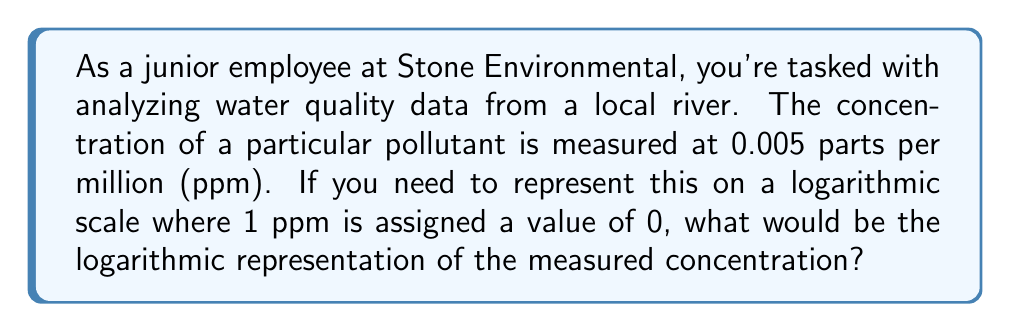Can you answer this question? To solve this problem, we'll follow these steps:

1) In a logarithmic scale, we're dealing with powers of 10. The general form of the scale is:

   $$ \text{Log value} = \log_{10}(\text{concentration}) - \log_{10}(\text{reference concentration}) $$

2) We're given that 1 ppm is assigned a value of 0 on this scale. This means 1 ppm is our reference concentration.

3) Let's plug in our values:
   - Measured concentration = 0.005 ppm
   - Reference concentration = 1 ppm

4) Now we can calculate:

   $$ \text{Log value} = \log_{10}(0.005) - \log_{10}(1) $$

5) Simplify:
   $$ \log_{10}(1) = 0 $$, so our equation becomes:
   $$ \text{Log value} = \log_{10}(0.005) - 0 = \log_{10}(0.005) $$

6) Calculate $\log_{10}(0.005)$:
   $$ \log_{10}(0.005) = \log_{10}(5 \times 10^{-3}) = \log_{10}(5) + \log_{10}(10^{-3}) = 0.6990 - 3 = -2.3010 $$

Therefore, the logarithmic representation of 0.005 ppm on this scale is approximately -2.3010.
Answer: -2.3010 